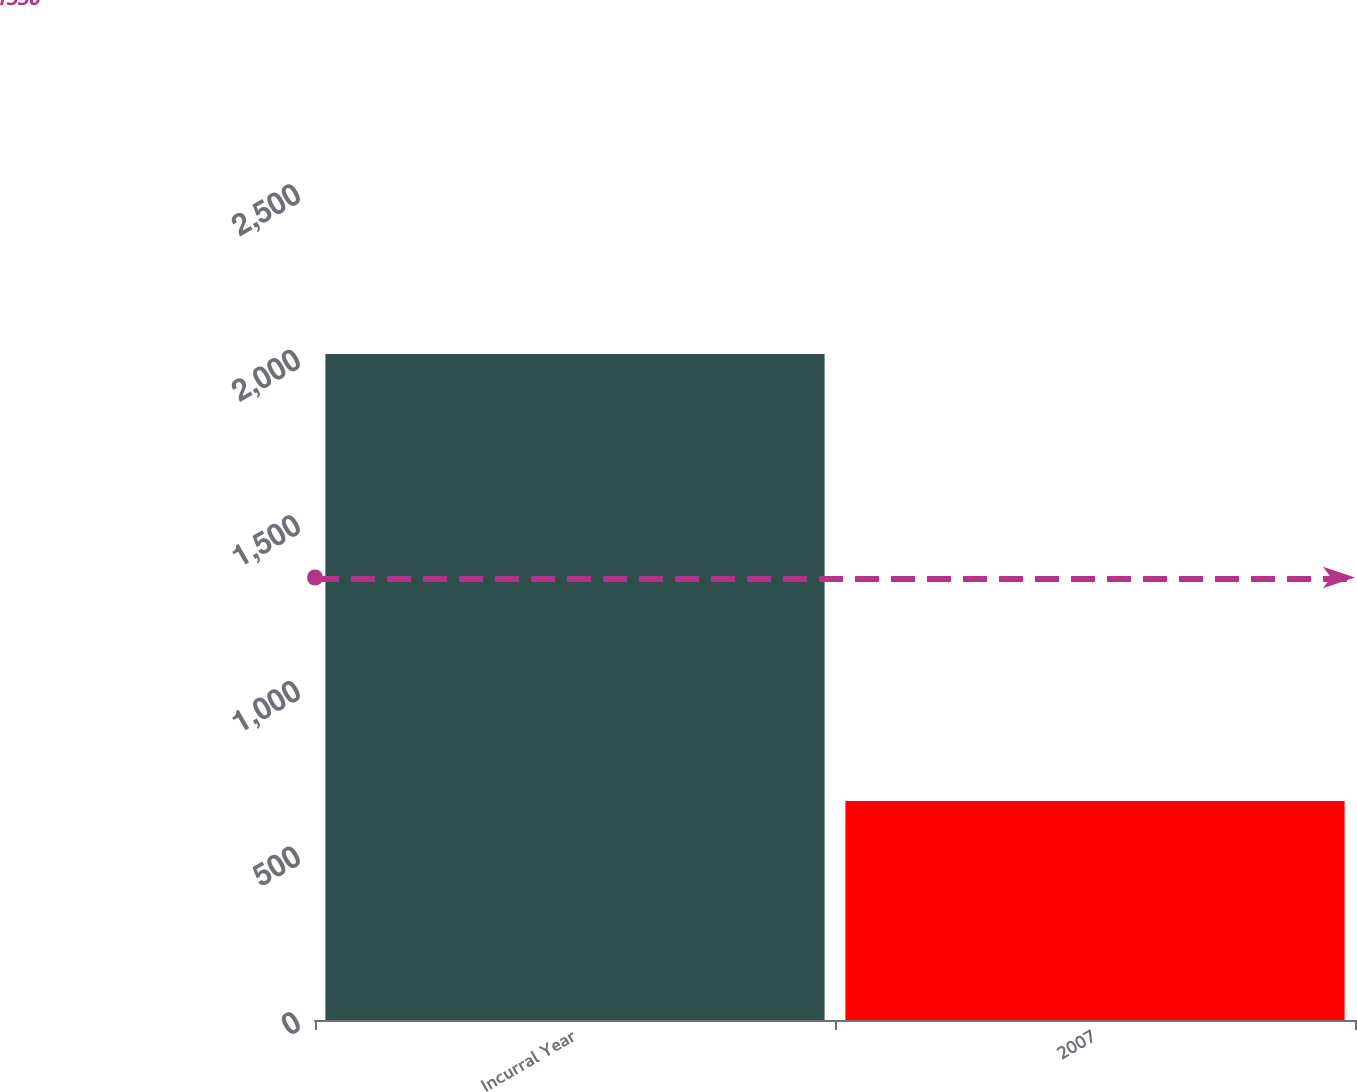Convert chart to OTSL. <chart><loc_0><loc_0><loc_500><loc_500><bar_chart><fcel>Incurral Year<fcel>2007<nl><fcel>2011<fcel>661<nl></chart> 